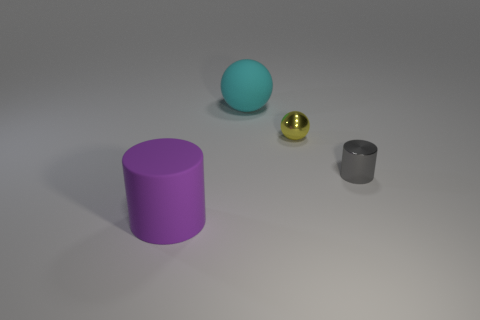The rubber sphere has what size?
Provide a short and direct response. Large. Are there any large rubber cylinders of the same color as the metal cylinder?
Provide a succinct answer. No. What number of big objects are matte things or matte cylinders?
Provide a short and direct response. 2. There is a thing that is in front of the cyan rubber object and behind the small cylinder; what is its size?
Offer a very short reply. Small. There is a large cylinder; how many tiny spheres are in front of it?
Ensure brevity in your answer.  0. The object that is behind the matte cylinder and to the left of the tiny yellow sphere has what shape?
Keep it short and to the point. Sphere. What number of cylinders are small gray matte things or large purple matte things?
Offer a very short reply. 1. Are there fewer big purple rubber things to the right of the cyan rubber object than green shiny spheres?
Your answer should be very brief. No. The object that is both behind the tiny gray metal cylinder and to the left of the tiny yellow sphere is what color?
Make the answer very short. Cyan. How many other objects are the same shape as the yellow shiny object?
Give a very brief answer. 1. 